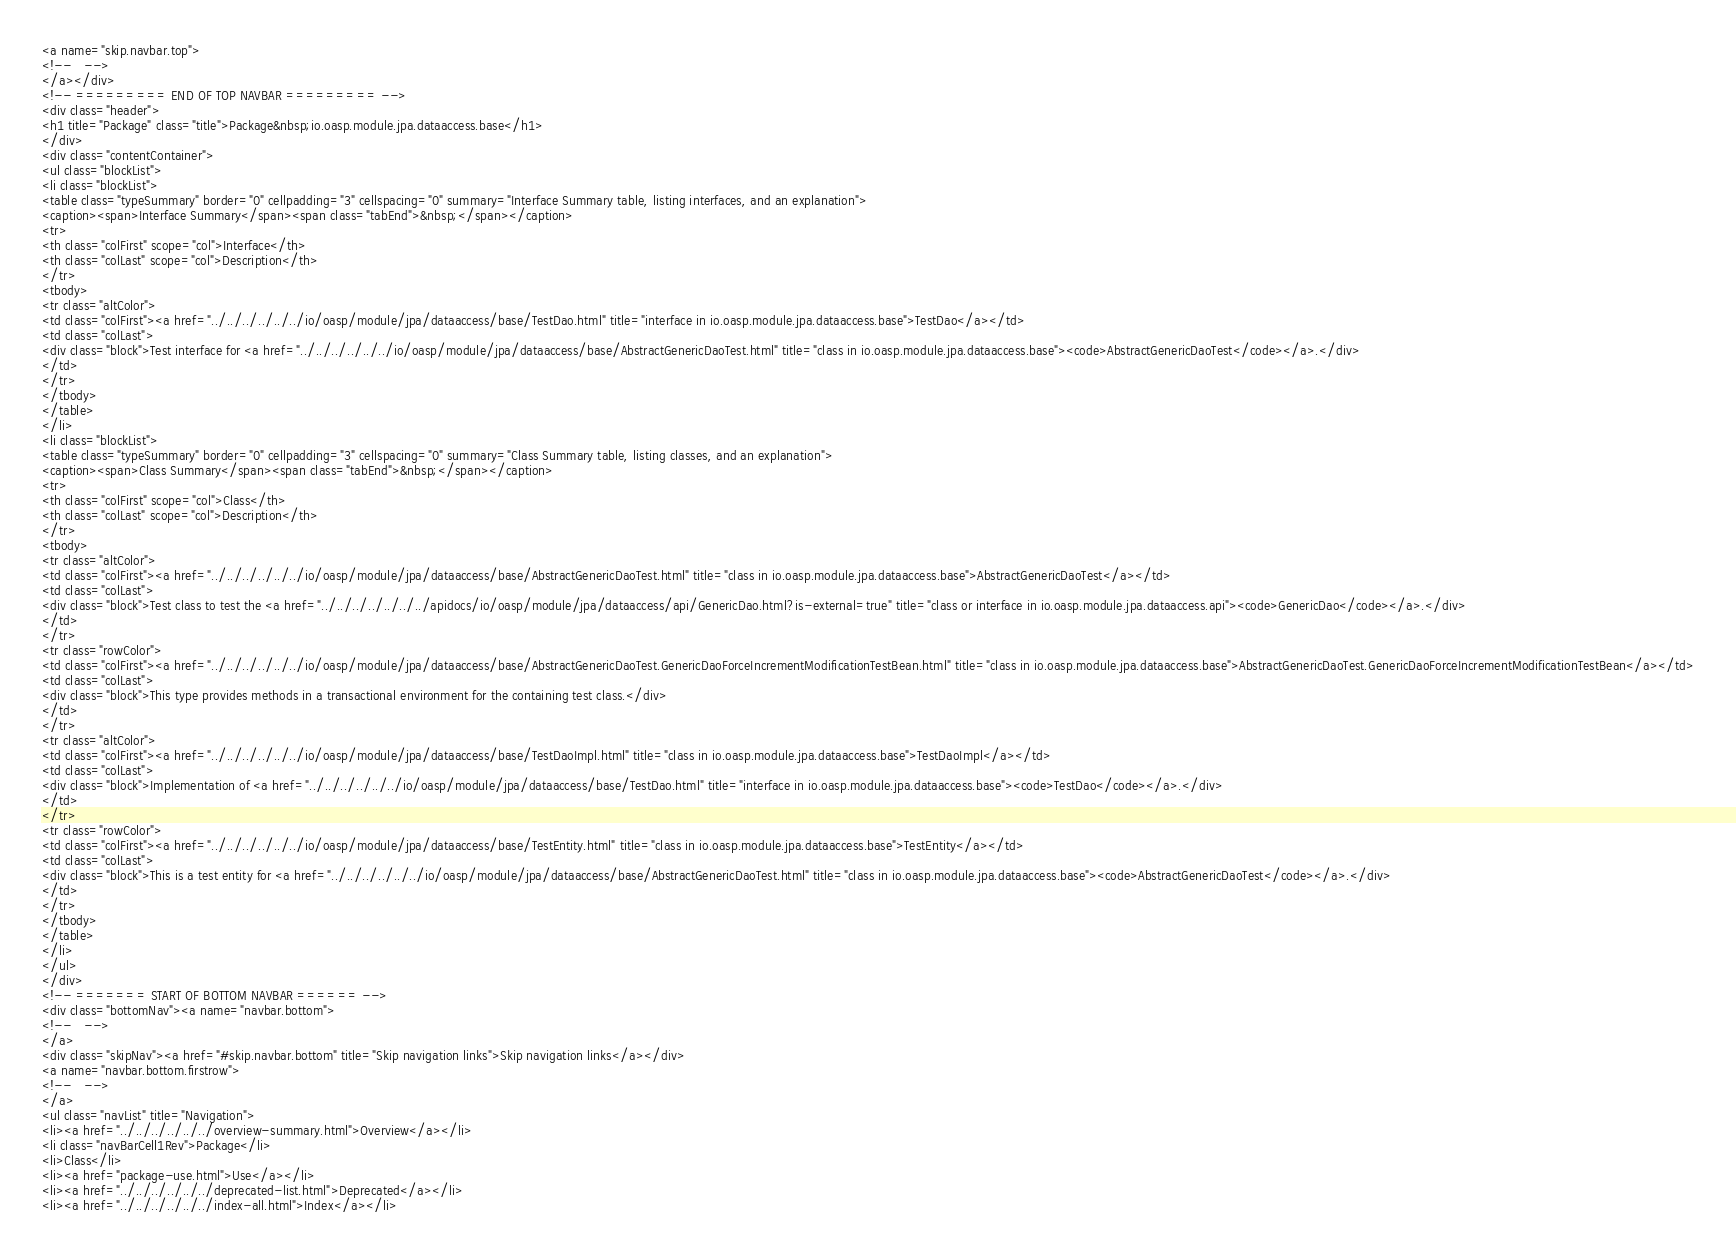Convert code to text. <code><loc_0><loc_0><loc_500><loc_500><_HTML_><a name="skip.navbar.top">
<!--   -->
</a></div>
<!-- ========= END OF TOP NAVBAR ========= -->
<div class="header">
<h1 title="Package" class="title">Package&nbsp;io.oasp.module.jpa.dataaccess.base</h1>
</div>
<div class="contentContainer">
<ul class="blockList">
<li class="blockList">
<table class="typeSummary" border="0" cellpadding="3" cellspacing="0" summary="Interface Summary table, listing interfaces, and an explanation">
<caption><span>Interface Summary</span><span class="tabEnd">&nbsp;</span></caption>
<tr>
<th class="colFirst" scope="col">Interface</th>
<th class="colLast" scope="col">Description</th>
</tr>
<tbody>
<tr class="altColor">
<td class="colFirst"><a href="../../../../../../io/oasp/module/jpa/dataaccess/base/TestDao.html" title="interface in io.oasp.module.jpa.dataaccess.base">TestDao</a></td>
<td class="colLast">
<div class="block">Test interface for <a href="../../../../../../io/oasp/module/jpa/dataaccess/base/AbstractGenericDaoTest.html" title="class in io.oasp.module.jpa.dataaccess.base"><code>AbstractGenericDaoTest</code></a>.</div>
</td>
</tr>
</tbody>
</table>
</li>
<li class="blockList">
<table class="typeSummary" border="0" cellpadding="3" cellspacing="0" summary="Class Summary table, listing classes, and an explanation">
<caption><span>Class Summary</span><span class="tabEnd">&nbsp;</span></caption>
<tr>
<th class="colFirst" scope="col">Class</th>
<th class="colLast" scope="col">Description</th>
</tr>
<tbody>
<tr class="altColor">
<td class="colFirst"><a href="../../../../../../io/oasp/module/jpa/dataaccess/base/AbstractGenericDaoTest.html" title="class in io.oasp.module.jpa.dataaccess.base">AbstractGenericDaoTest</a></td>
<td class="colLast">
<div class="block">Test class to test the <a href="../../../../../../../apidocs/io/oasp/module/jpa/dataaccess/api/GenericDao.html?is-external=true" title="class or interface in io.oasp.module.jpa.dataaccess.api"><code>GenericDao</code></a>.</div>
</td>
</tr>
<tr class="rowColor">
<td class="colFirst"><a href="../../../../../../io/oasp/module/jpa/dataaccess/base/AbstractGenericDaoTest.GenericDaoForceIncrementModificationTestBean.html" title="class in io.oasp.module.jpa.dataaccess.base">AbstractGenericDaoTest.GenericDaoForceIncrementModificationTestBean</a></td>
<td class="colLast">
<div class="block">This type provides methods in a transactional environment for the containing test class.</div>
</td>
</tr>
<tr class="altColor">
<td class="colFirst"><a href="../../../../../../io/oasp/module/jpa/dataaccess/base/TestDaoImpl.html" title="class in io.oasp.module.jpa.dataaccess.base">TestDaoImpl</a></td>
<td class="colLast">
<div class="block">Implementation of <a href="../../../../../../io/oasp/module/jpa/dataaccess/base/TestDao.html" title="interface in io.oasp.module.jpa.dataaccess.base"><code>TestDao</code></a>.</div>
</td>
</tr>
<tr class="rowColor">
<td class="colFirst"><a href="../../../../../../io/oasp/module/jpa/dataaccess/base/TestEntity.html" title="class in io.oasp.module.jpa.dataaccess.base">TestEntity</a></td>
<td class="colLast">
<div class="block">This is a test entity for <a href="../../../../../../io/oasp/module/jpa/dataaccess/base/AbstractGenericDaoTest.html" title="class in io.oasp.module.jpa.dataaccess.base"><code>AbstractGenericDaoTest</code></a>.</div>
</td>
</tr>
</tbody>
</table>
</li>
</ul>
</div>
<!-- ======= START OF BOTTOM NAVBAR ====== -->
<div class="bottomNav"><a name="navbar.bottom">
<!--   -->
</a>
<div class="skipNav"><a href="#skip.navbar.bottom" title="Skip navigation links">Skip navigation links</a></div>
<a name="navbar.bottom.firstrow">
<!--   -->
</a>
<ul class="navList" title="Navigation">
<li><a href="../../../../../../overview-summary.html">Overview</a></li>
<li class="navBarCell1Rev">Package</li>
<li>Class</li>
<li><a href="package-use.html">Use</a></li>
<li><a href="../../../../../../deprecated-list.html">Deprecated</a></li>
<li><a href="../../../../../../index-all.html">Index</a></li></code> 